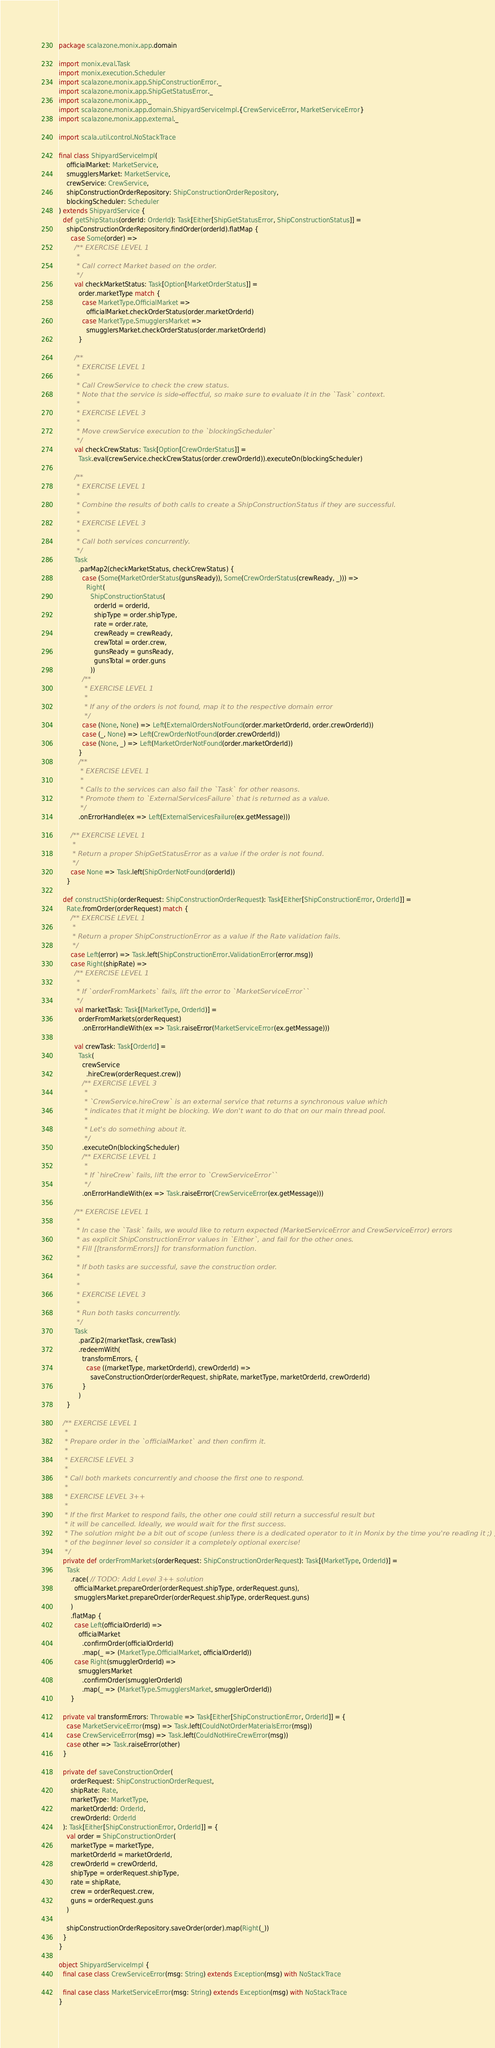Convert code to text. <code><loc_0><loc_0><loc_500><loc_500><_Scala_>package scalazone.monix.app.domain

import monix.eval.Task
import monix.execution.Scheduler
import scalazone.monix.app.ShipConstructionError._
import scalazone.monix.app.ShipGetStatusError._
import scalazone.monix.app._
import scalazone.monix.app.domain.ShipyardServiceImpl.{CrewServiceError, MarketServiceError}
import scalazone.monix.app.external._

import scala.util.control.NoStackTrace

final class ShipyardServiceImpl(
    officialMarket: MarketService,
    smugglersMarket: MarketService,
    crewService: CrewService,
    shipConstructionOrderRepository: ShipConstructionOrderRepository,
    blockingScheduler: Scheduler
) extends ShipyardService {
  def getShipStatus(orderId: OrderId): Task[Either[ShipGetStatusError, ShipConstructionStatus]] =
    shipConstructionOrderRepository.findOrder(orderId).flatMap {
      case Some(order) =>
        /** EXERCISE LEVEL 1
         *
         * Call correct Market based on the order.
         */
        val checkMarketStatus: Task[Option[MarketOrderStatus]] =
          order.marketType match {
            case MarketType.OfficialMarket =>
              officialMarket.checkOrderStatus(order.marketOrderId)
            case MarketType.SmugglersMarket =>
              smugglersMarket.checkOrderStatus(order.marketOrderId)
          }
          
        /**
         * EXERCISE LEVEL 1
         *
         * Call CrewService to check the crew status.
         * Note that the service is side-effectful, so make sure to evaluate it in the `Task` context.
         *
         * EXERCISE LEVEL 3
         *
         * Move crewService execution to the `blockingScheduler`
         */
        val checkCrewStatus: Task[Option[CrewOrderStatus]] =
          Task.eval(crewService.checkCrewStatus(order.crewOrderId)).executeOn(blockingScheduler)

        /**
         * EXERCISE LEVEL 1
         *
         * Combine the results of both calls to create a ShipConstructionStatus if they are successful.
         *
         * EXERCISE LEVEL 3
         *
         * Call both services concurrently.
         */
        Task
          .parMap2(checkMarketStatus, checkCrewStatus) {
            case (Some(MarketOrderStatus(gunsReady)), Some(CrewOrderStatus(crewReady, _))) =>
              Right(
                ShipConstructionStatus(
                  orderId = orderId,
                  shipType = order.shipType,
                  rate = order.rate,
                  crewReady = crewReady,
                  crewTotal = order.crew,
                  gunsReady = gunsReady,
                  gunsTotal = order.guns
                ))
            /**
             * EXERCISE LEVEL 1
             *
             * If any of the orders is not found, map it to the respective domain error
             */
            case (None, None) => Left(ExternalOrdersNotFound(order.marketOrderId, order.crewOrderId))
            case (_, None) => Left(CrewOrderNotFound(order.crewOrderId))
            case (None, _) => Left(MarketOrderNotFound(order.marketOrderId))
          }
          /**
           * EXERCISE LEVEL 1
           *
           * Calls to the services can also fail the `Task` for other reasons.
           * Promote them to `ExternalServicesFailure` that is returned as a value.
           */
          .onErrorHandle(ex => Left(ExternalServicesFailure(ex.getMessage)))

      /** EXERCISE LEVEL 1
       *
       * Return a proper ShipGetStatusError as a value if the order is not found.
       */
      case None => Task.left(ShipOrderNotFound(orderId))
    }

  def constructShip(orderRequest: ShipConstructionOrderRequest): Task[Either[ShipConstructionError, OrderId]] =
    Rate.fromOrder(orderRequest) match {
      /** EXERCISE LEVEL 1
       *
       * Return a proper ShipConstructionError as a value if the Rate validation fails.
       */
      case Left(error) => Task.left(ShipConstructionError.ValidationError(error.msg))
      case Right(shipRate) =>
        /** EXERCISE LEVEL 1
         *
         * If `orderFromMarkets` fails, lift the error to `MarketServiceError``
         */
        val marketTask: Task[(MarketType, OrderId)] =
          orderFromMarkets(orderRequest)
            .onErrorHandleWith(ex => Task.raiseError(MarketServiceError(ex.getMessage)))

        val crewTask: Task[OrderId] =
          Task(
            crewService
              .hireCrew(orderRequest.crew))
            /** EXERCISE LEVEL 3
             *
             * `CrewService.hireCrew` is an external service that returns a synchronous value which
             * indicates that it might be blocking. We don't want to do that on our main thread pool.
             *
             * Let's do something about it.
             */
            .executeOn(blockingScheduler)
            /** EXERCISE LEVEL 1
             *
             * If `hireCrew` fails, lift the error to `CrewServiceError``
             */
            .onErrorHandleWith(ex => Task.raiseError(CrewServiceError(ex.getMessage)))

        /** EXERCISE LEVEL 1
         *
         * In case the `Task` fails, we would like to return expected (MarketServiceError and CrewServiceError) errors 
         * as explicit ShipConstructionError values in `Either`, and fail for the other ones.
         * Fill [[transformErrors]] for transformation function.
         *
         * If both tasks are successful, save the construction order.
         *
         *
         * EXERCISE LEVEL 3
         *
         * Run both tasks concurrently.
         */
        Task
          .parZip2(marketTask, crewTask)
          .redeemWith(
            transformErrors, {
              case ((marketType, marketOrderId), crewOrderId) =>
                saveConstructionOrder(orderRequest, shipRate, marketType, marketOrderId, crewOrderId)
            }
          )
    }

  /** EXERCISE LEVEL 1
   *
   * Prepare order in the `officialMarket` and then confirm it.
   *
   * EXERCISE LEVEL 3
   *
   * Call both markets concurrently and choose the first one to respond.
   *
   * EXERCISE LEVEL 3++
   *
   * If the first Market to respond fails, the other one could still return a successful result but
   * it will be cancelled. Ideally, we would wait for the first success.
   * The solution might be a bit out of scope (unless there is a dedicated operator to it in Monix by the time you're reading it ;) )
   * of the beginner level so consider it a completely optional exercise!
   */
  private def orderFromMarkets(orderRequest: ShipConstructionOrderRequest): Task[(MarketType, OrderId)] =
    Task
      .race( // TODO: Add Level 3++ solution
        officialMarket.prepareOrder(orderRequest.shipType, orderRequest.guns),
        smugglersMarket.prepareOrder(orderRequest.shipType, orderRequest.guns)
      )
      .flatMap {
        case Left(officialOrderId) =>
          officialMarket
            .confirmOrder(officialOrderId)
            .map(_ => (MarketType.OfficialMarket, officialOrderId))
        case Right(smugglerOrderId) =>
          smugglersMarket
            .confirmOrder(smugglerOrderId)
            .map(_ => (MarketType.SmugglersMarket, smugglerOrderId))
      }

  private val transformErrors: Throwable => Task[Either[ShipConstructionError, OrderId]] = {
    case MarketServiceError(msg) => Task.left(CouldNotOrderMaterialsError(msg))
    case CrewServiceError(msg) => Task.left(CouldNotHireCrewError(msg))
    case other => Task.raiseError(other)
  }

  private def saveConstructionOrder(
      orderRequest: ShipConstructionOrderRequest,
      shipRate: Rate,
      marketType: MarketType,
      marketOrderId: OrderId,
      crewOrderId: OrderId
  ): Task[Either[ShipConstructionError, OrderId]] = {
    val order = ShipConstructionOrder(
      marketType = marketType,
      marketOrderId = marketOrderId,
      crewOrderId = crewOrderId,
      shipType = orderRequest.shipType,
      rate = shipRate,
      crew = orderRequest.crew,
      guns = orderRequest.guns
    )

    shipConstructionOrderRepository.saveOrder(order).map(Right(_))
  }
}

object ShipyardServiceImpl {
  final case class CrewServiceError(msg: String) extends Exception(msg) with NoStackTrace

  final case class MarketServiceError(msg: String) extends Exception(msg) with NoStackTrace
}
</code> 